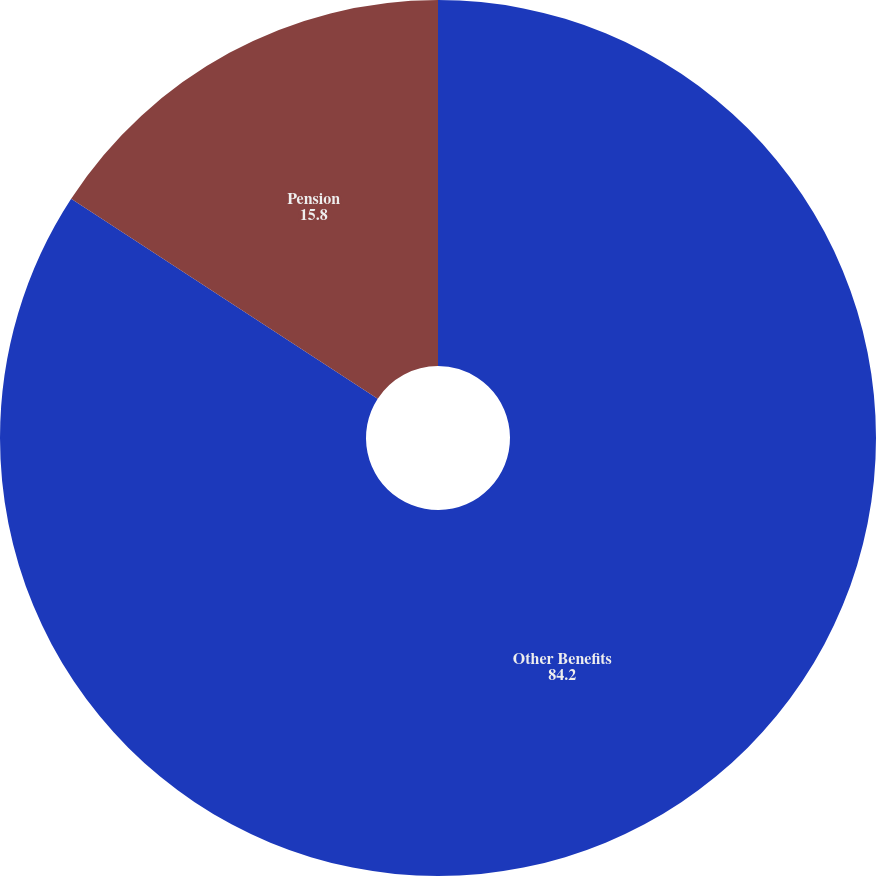<chart> <loc_0><loc_0><loc_500><loc_500><pie_chart><fcel>Other Benefits<fcel>Pension<nl><fcel>84.2%<fcel>15.8%<nl></chart> 